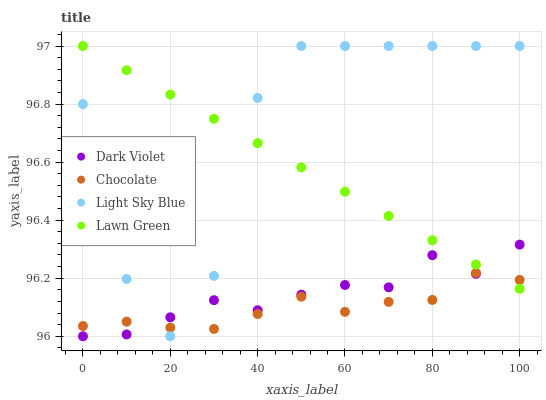Does Chocolate have the minimum area under the curve?
Answer yes or no. Yes. Does Light Sky Blue have the maximum area under the curve?
Answer yes or no. Yes. Does Dark Violet have the minimum area under the curve?
Answer yes or no. No. Does Dark Violet have the maximum area under the curve?
Answer yes or no. No. Is Lawn Green the smoothest?
Answer yes or no. Yes. Is Light Sky Blue the roughest?
Answer yes or no. Yes. Is Dark Violet the smoothest?
Answer yes or no. No. Is Dark Violet the roughest?
Answer yes or no. No. Does Dark Violet have the lowest value?
Answer yes or no. Yes. Does Light Sky Blue have the lowest value?
Answer yes or no. No. Does Light Sky Blue have the highest value?
Answer yes or no. Yes. Does Dark Violet have the highest value?
Answer yes or no. No. Does Lawn Green intersect Light Sky Blue?
Answer yes or no. Yes. Is Lawn Green less than Light Sky Blue?
Answer yes or no. No. Is Lawn Green greater than Light Sky Blue?
Answer yes or no. No. 